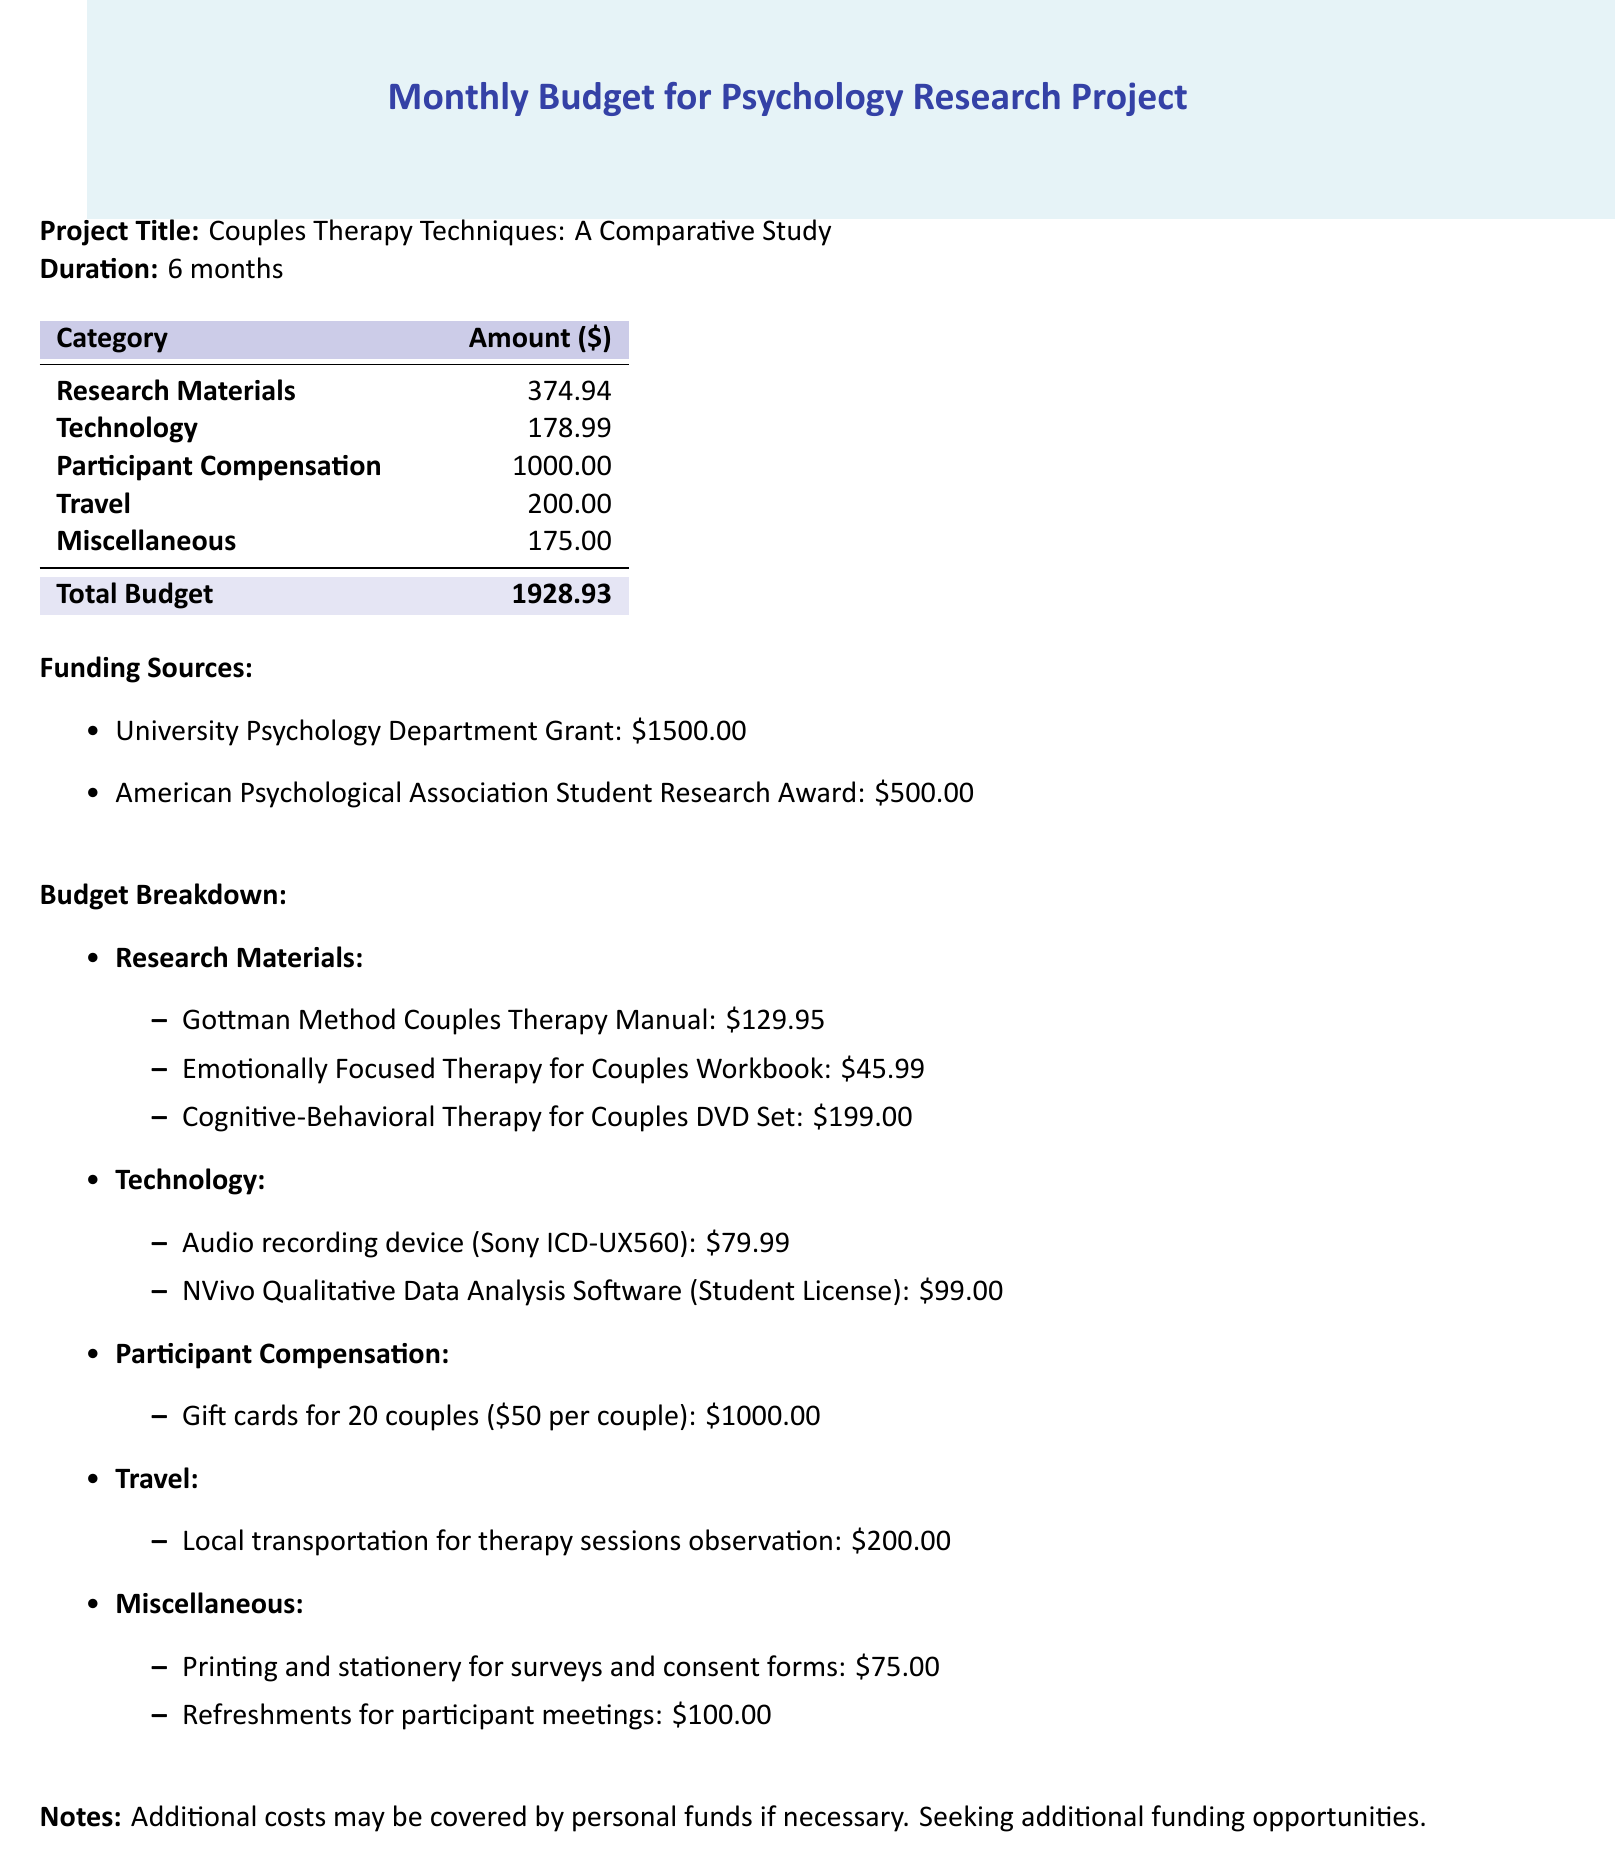What is the total budget? The total budget is present in the summary section of the document calculated from all expense categories.
Answer: 1928.93 What is the funding amount from the University Psychology Department Grant? The funding sources list the specific amounts received from different organizations.
Answer: 1500.00 How much is allocated for Participant Compensation? Participant compensation is a distinct category with its specific amount outlined in the budget.
Answer: 1000.00 What is the name of one therapy manual included in the research materials? The budget breakdown lists specific items purchased under research materials, including therapy manuals.
Answer: Gottman Method Couples Therapy Manual How much is the cost of the Audio recording device? The technology section details specific items and their associated costs.
Answer: 79.99 What is the total amount budgeted for travel expenses? The travel category includes specific transportation costs associated with the project.
Answer: 200.00 How many couples will receive gift cards as participant compensation? The participant compensation section specifies the number of couples included in this budget category.
Answer: 20 What is the total cost for printing and stationery in the miscellaneous category? The miscellaneous section details all costs associated with this category, including printing and stationery.
Answer: 75.00 What software is purchased for qualitative data analysis? The technology section lists the software included in the budget for research purposes.
Answer: NVivo Qualitative Data Analysis Software (Student License) 